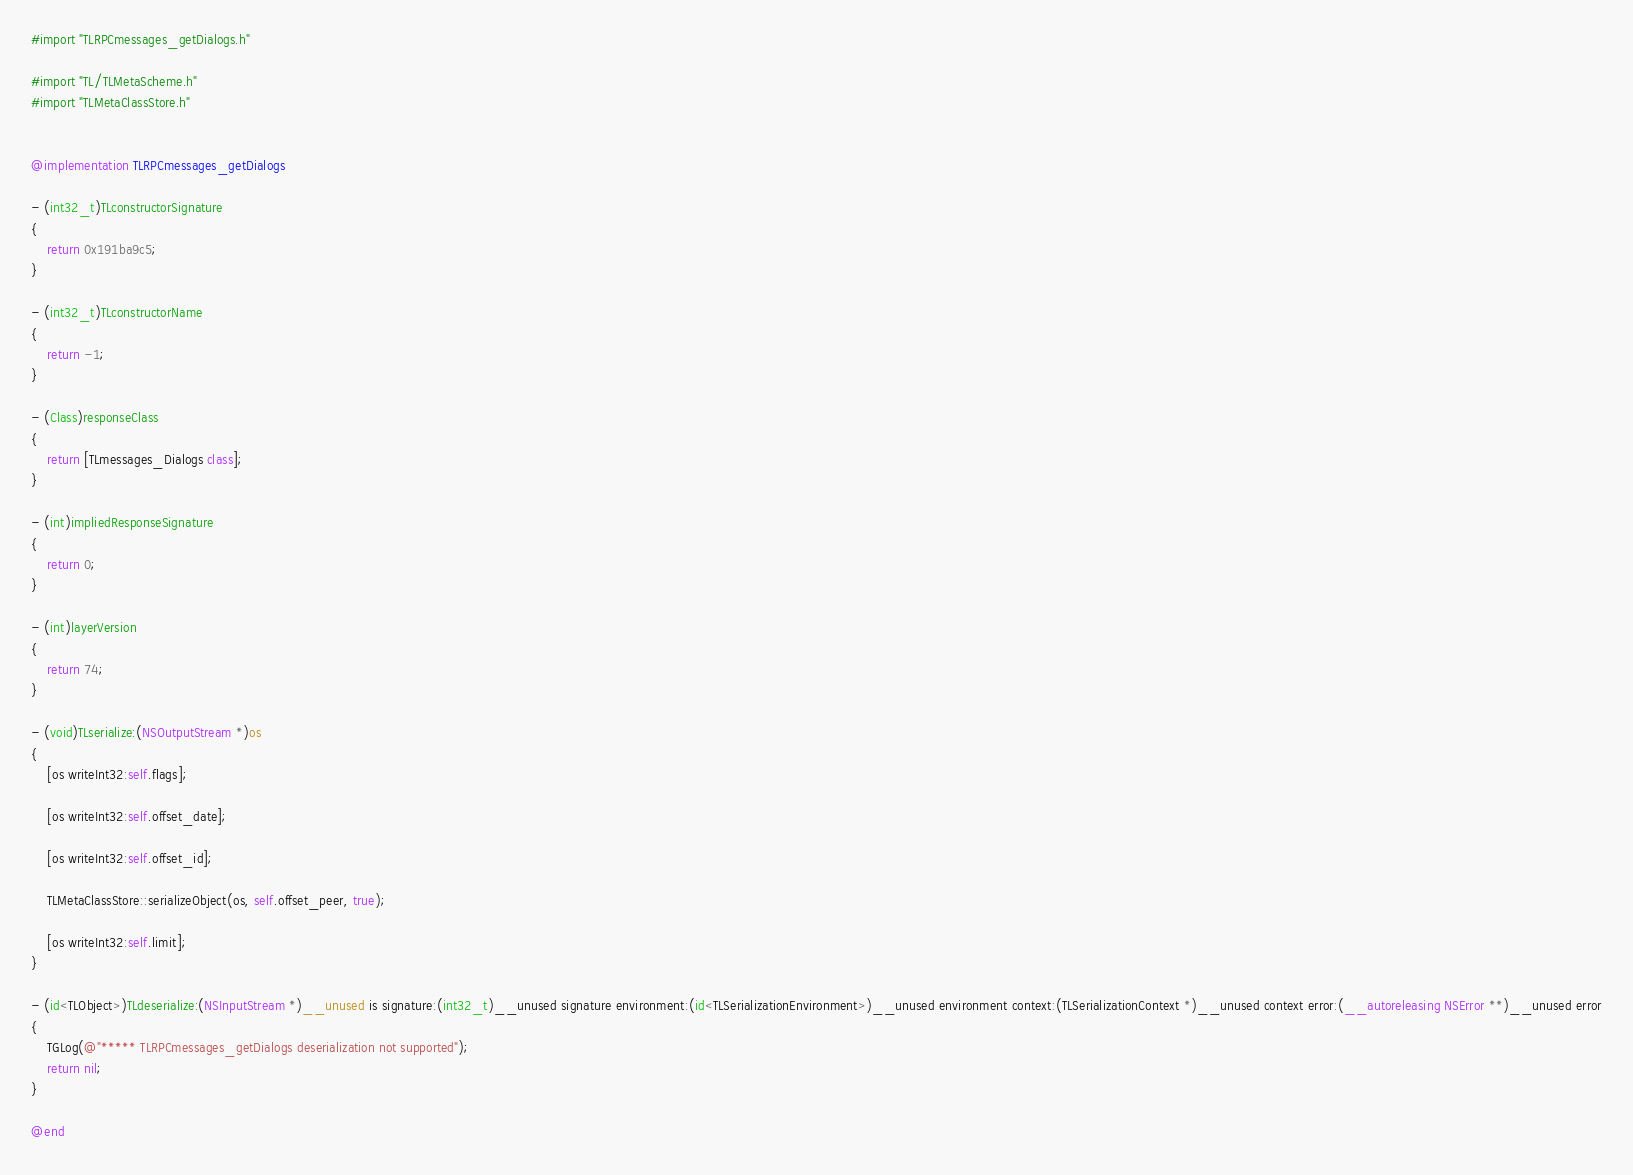Convert code to text. <code><loc_0><loc_0><loc_500><loc_500><_ObjectiveC_>#import "TLRPCmessages_getDialogs.h"

#import "TL/TLMetaScheme.h"
#import "TLMetaClassStore.h"


@implementation TLRPCmessages_getDialogs

- (int32_t)TLconstructorSignature
{
    return 0x191ba9c5;
}

- (int32_t)TLconstructorName
{
    return -1;
}

- (Class)responseClass
{
    return [TLmessages_Dialogs class];
}

- (int)impliedResponseSignature
{
    return 0;
}

- (int)layerVersion
{
    return 74;
}

- (void)TLserialize:(NSOutputStream *)os
{
    [os writeInt32:self.flags];
    
    [os writeInt32:self.offset_date];
    
    [os writeInt32:self.offset_id];
    
    TLMetaClassStore::serializeObject(os, self.offset_peer, true);

    [os writeInt32:self.limit];
}

- (id<TLObject>)TLdeserialize:(NSInputStream *)__unused is signature:(int32_t)__unused signature environment:(id<TLSerializationEnvironment>)__unused environment context:(TLSerializationContext *)__unused context error:(__autoreleasing NSError **)__unused error
{
    TGLog(@"***** TLRPCmessages_getDialogs deserialization not supported");
    return nil;
}

@end

</code> 